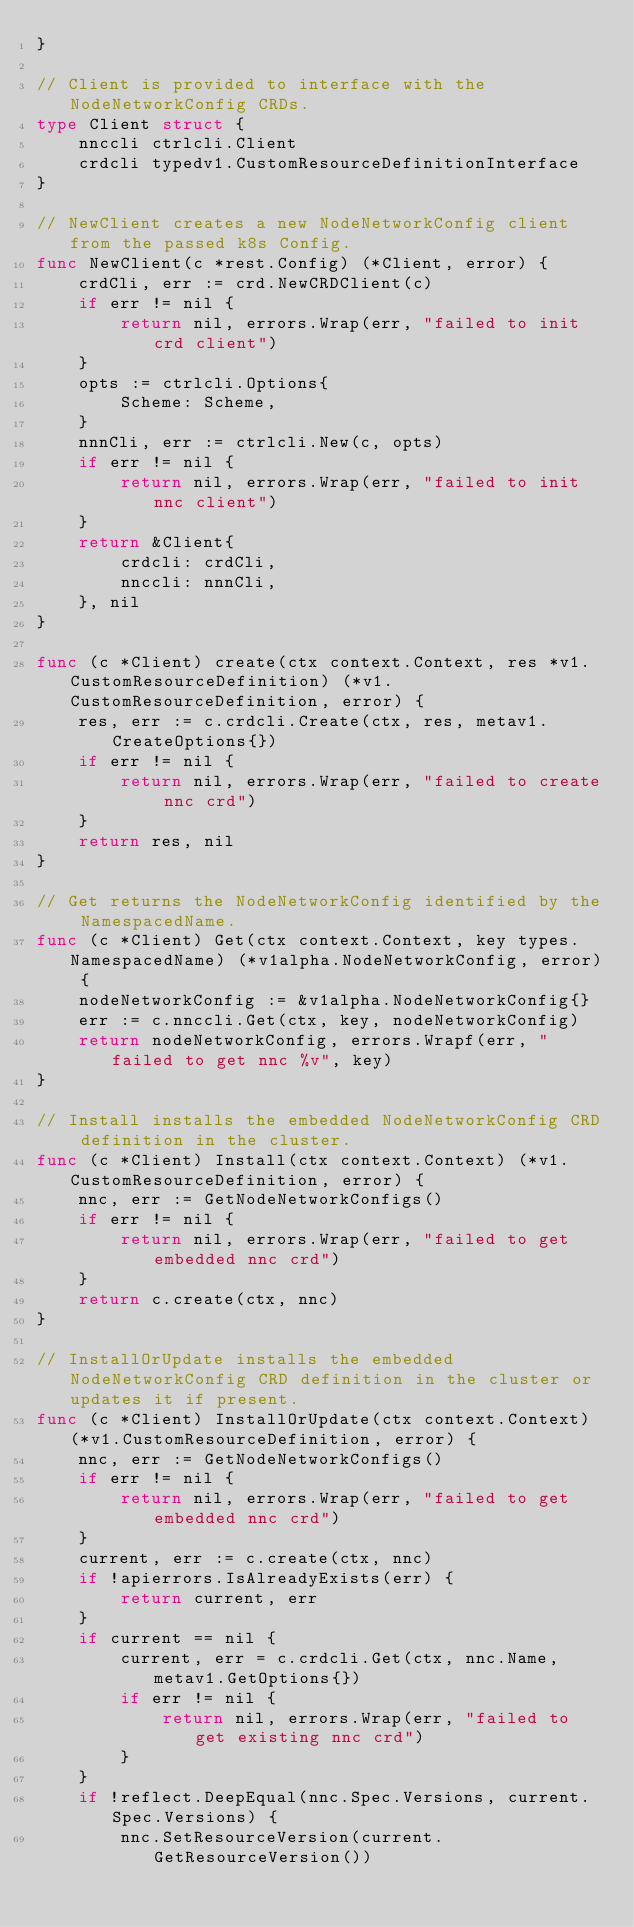Convert code to text. <code><loc_0><loc_0><loc_500><loc_500><_Go_>}

// Client is provided to interface with the NodeNetworkConfig CRDs.
type Client struct {
	nnccli ctrlcli.Client
	crdcli typedv1.CustomResourceDefinitionInterface
}

// NewClient creates a new NodeNetworkConfig client from the passed k8s Config.
func NewClient(c *rest.Config) (*Client, error) {
	crdCli, err := crd.NewCRDClient(c)
	if err != nil {
		return nil, errors.Wrap(err, "failed to init crd client")
	}
	opts := ctrlcli.Options{
		Scheme: Scheme,
	}
	nnnCli, err := ctrlcli.New(c, opts)
	if err != nil {
		return nil, errors.Wrap(err, "failed to init nnc client")
	}
	return &Client{
		crdcli: crdCli,
		nnccli: nnnCli,
	}, nil
}

func (c *Client) create(ctx context.Context, res *v1.CustomResourceDefinition) (*v1.CustomResourceDefinition, error) {
	res, err := c.crdcli.Create(ctx, res, metav1.CreateOptions{})
	if err != nil {
		return nil, errors.Wrap(err, "failed to create nnc crd")
	}
	return res, nil
}

// Get returns the NodeNetworkConfig identified by the NamespacedName.
func (c *Client) Get(ctx context.Context, key types.NamespacedName) (*v1alpha.NodeNetworkConfig, error) {
	nodeNetworkConfig := &v1alpha.NodeNetworkConfig{}
	err := c.nnccli.Get(ctx, key, nodeNetworkConfig)
	return nodeNetworkConfig, errors.Wrapf(err, "failed to get nnc %v", key)
}

// Install installs the embedded NodeNetworkConfig CRD definition in the cluster.
func (c *Client) Install(ctx context.Context) (*v1.CustomResourceDefinition, error) {
	nnc, err := GetNodeNetworkConfigs()
	if err != nil {
		return nil, errors.Wrap(err, "failed to get embedded nnc crd")
	}
	return c.create(ctx, nnc)
}

// InstallOrUpdate installs the embedded NodeNetworkConfig CRD definition in the cluster or updates it if present.
func (c *Client) InstallOrUpdate(ctx context.Context) (*v1.CustomResourceDefinition, error) {
	nnc, err := GetNodeNetworkConfigs()
	if err != nil {
		return nil, errors.Wrap(err, "failed to get embedded nnc crd")
	}
	current, err := c.create(ctx, nnc)
	if !apierrors.IsAlreadyExists(err) {
		return current, err
	}
	if current == nil {
		current, err = c.crdcli.Get(ctx, nnc.Name, metav1.GetOptions{})
		if err != nil {
			return nil, errors.Wrap(err, "failed to get existing nnc crd")
		}
	}
	if !reflect.DeepEqual(nnc.Spec.Versions, current.Spec.Versions) {
		nnc.SetResourceVersion(current.GetResourceVersion())</code> 